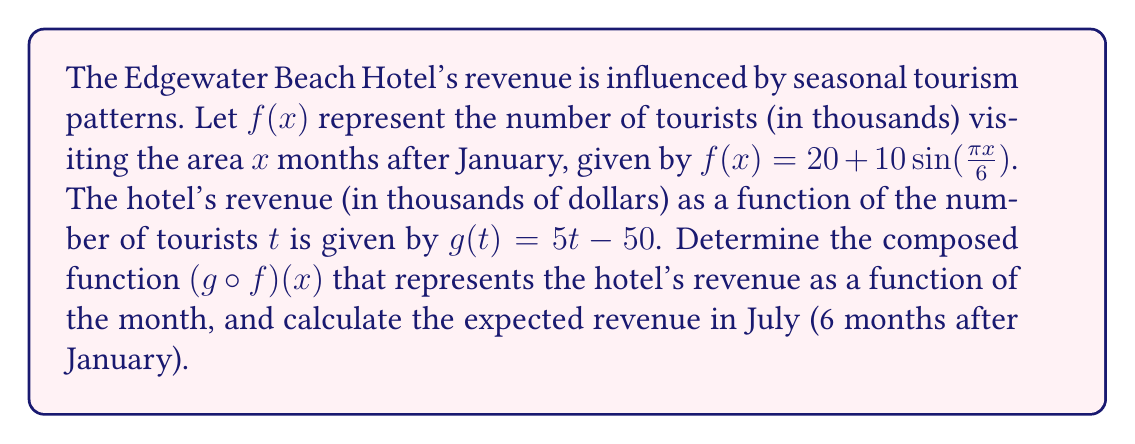Show me your answer to this math problem. 1) First, we need to compose the functions $g$ and $f$. The composition $(g \circ f)(x)$ means we replace $t$ in $g(t)$ with $f(x)$:

   $(g \circ f)(x) = g(f(x)) = 5(f(x)) - 50$

2) Now, we substitute the expression for $f(x)$:

   $(g \circ f)(x) = 5(20 + 10\sin(\frac{\pi x}{6})) - 50$

3) Simplify:
   
   $(g \circ f)(x) = 100 + 50\sin(\frac{\pi x}{6}) - 50 = 50 + 50\sin(\frac{\pi x}{6})$

4) This is our composed function representing revenue based on the month.

5) To find the revenue in July, we substitute $x = 6$ (as July is 6 months after January):

   $(g \circ f)(6) = 50 + 50\sin(\frac{\pi \cdot 6}{6}) = 50 + 50\sin(\pi) = 50 + 50 \cdot 0 = 50$

Therefore, the expected revenue in July is $50,000.
Answer: $(g \circ f)(x) = 50 + 50\sin(\frac{\pi x}{6})$; July revenue: $50,000 